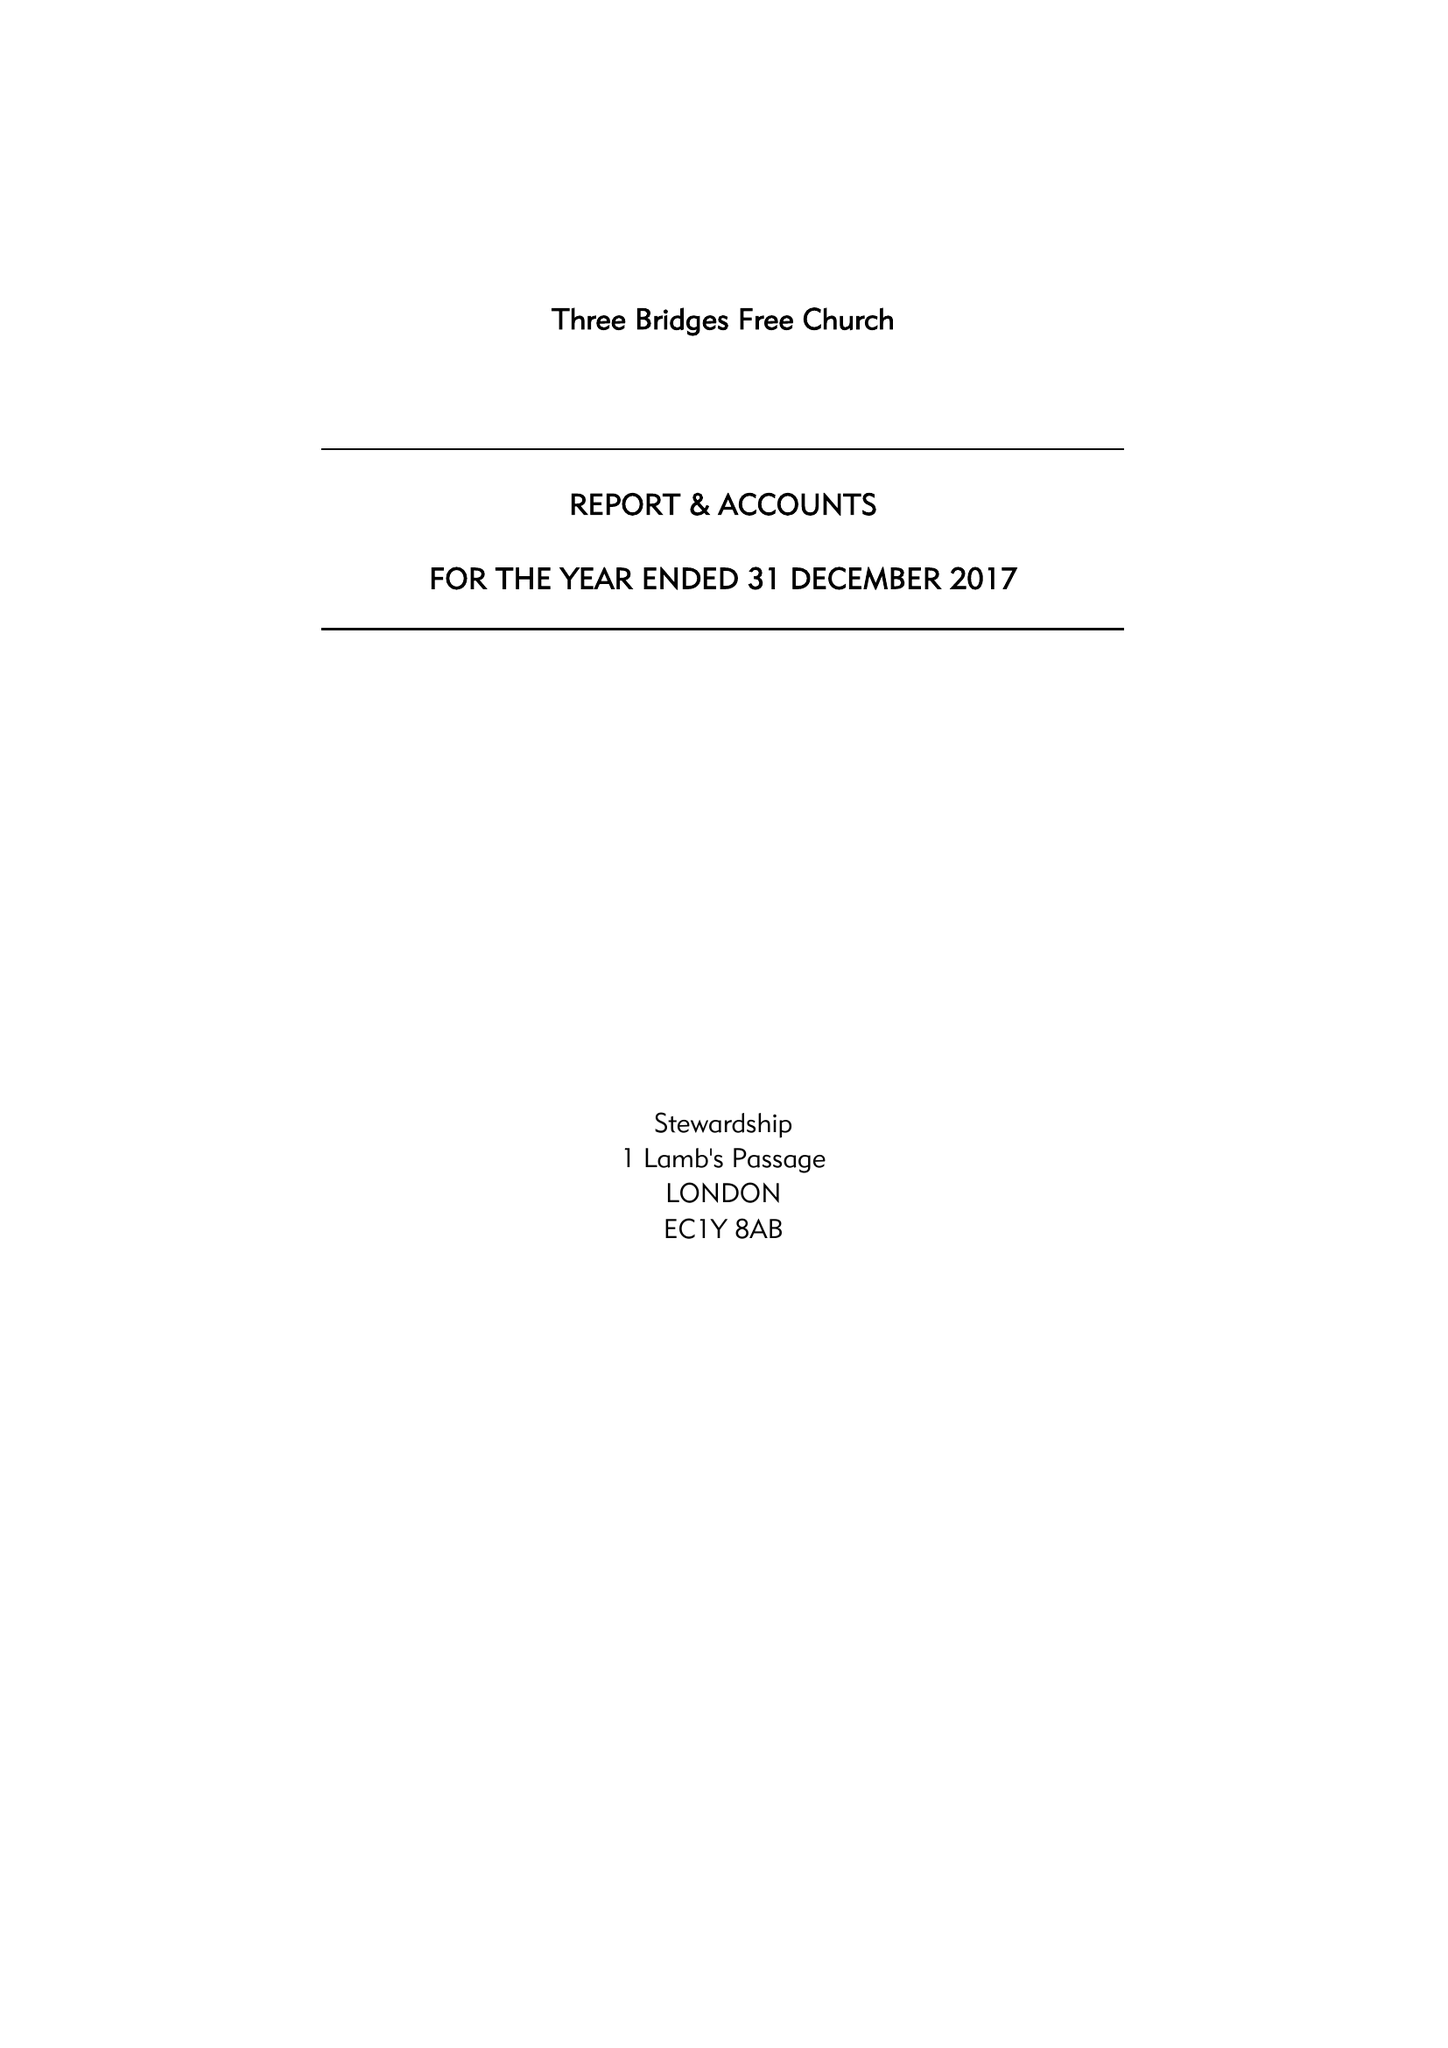What is the value for the report_date?
Answer the question using a single word or phrase. 2017-12-31 